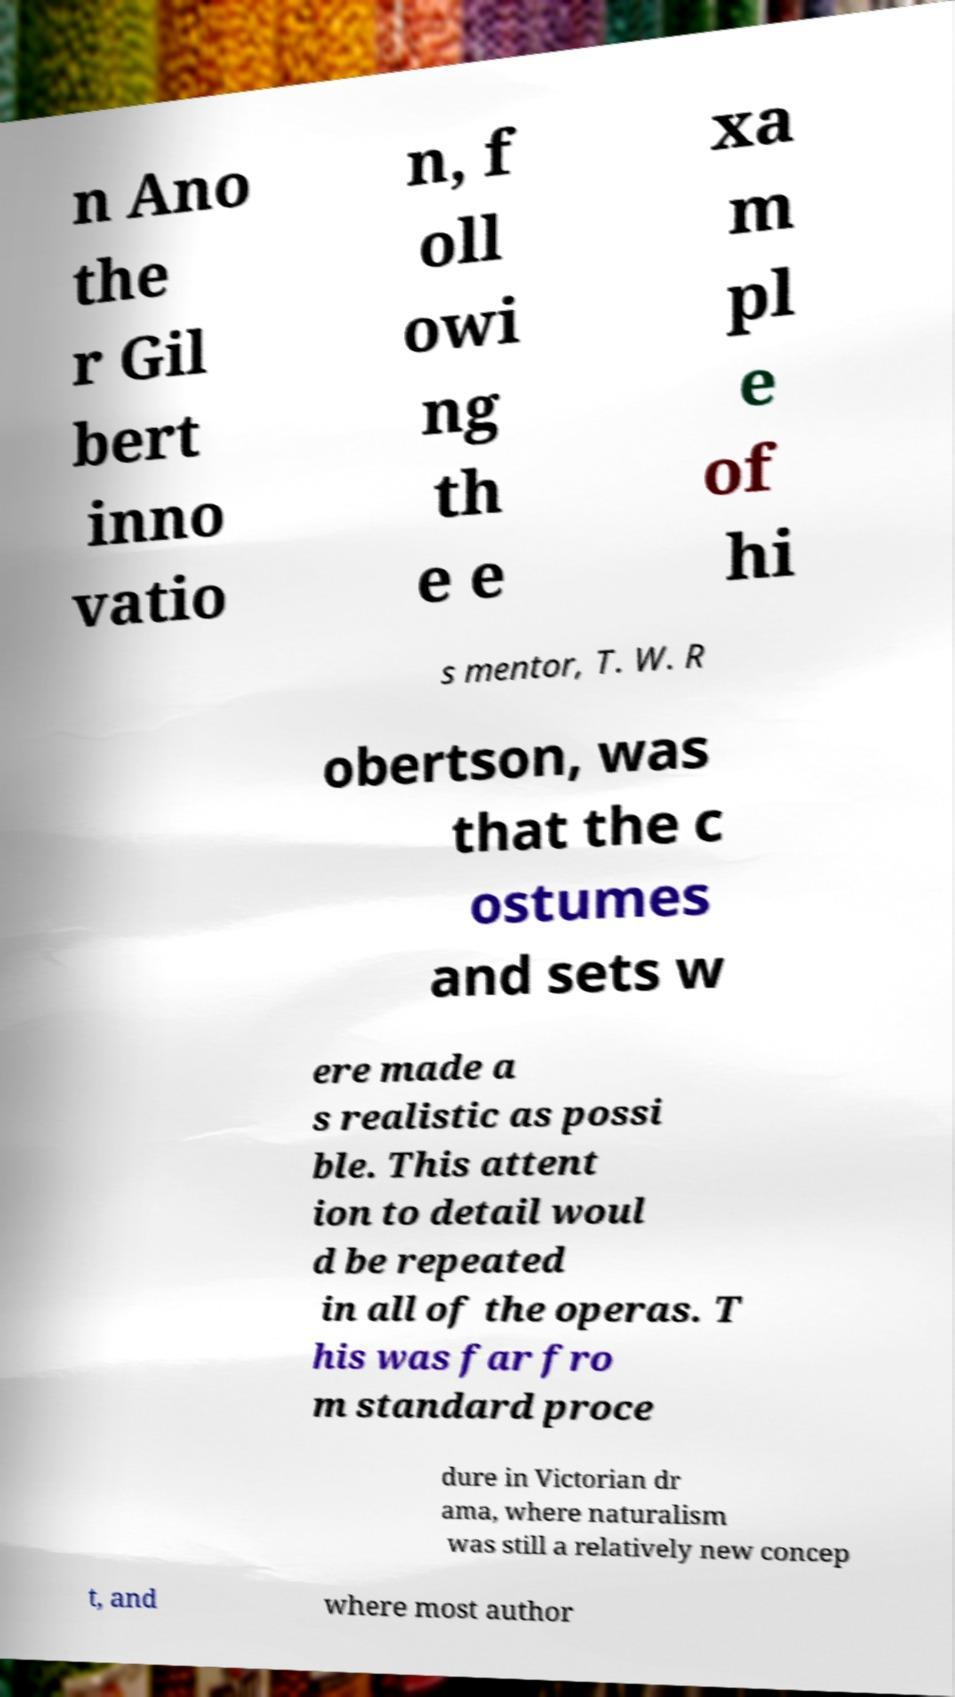There's text embedded in this image that I need extracted. Can you transcribe it verbatim? n Ano the r Gil bert inno vatio n, f oll owi ng th e e xa m pl e of hi s mentor, T. W. R obertson, was that the c ostumes and sets w ere made a s realistic as possi ble. This attent ion to detail woul d be repeated in all of the operas. T his was far fro m standard proce dure in Victorian dr ama, where naturalism was still a relatively new concep t, and where most author 